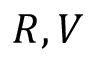<formula> <loc_0><loc_0><loc_500><loc_500>R , V</formula> 